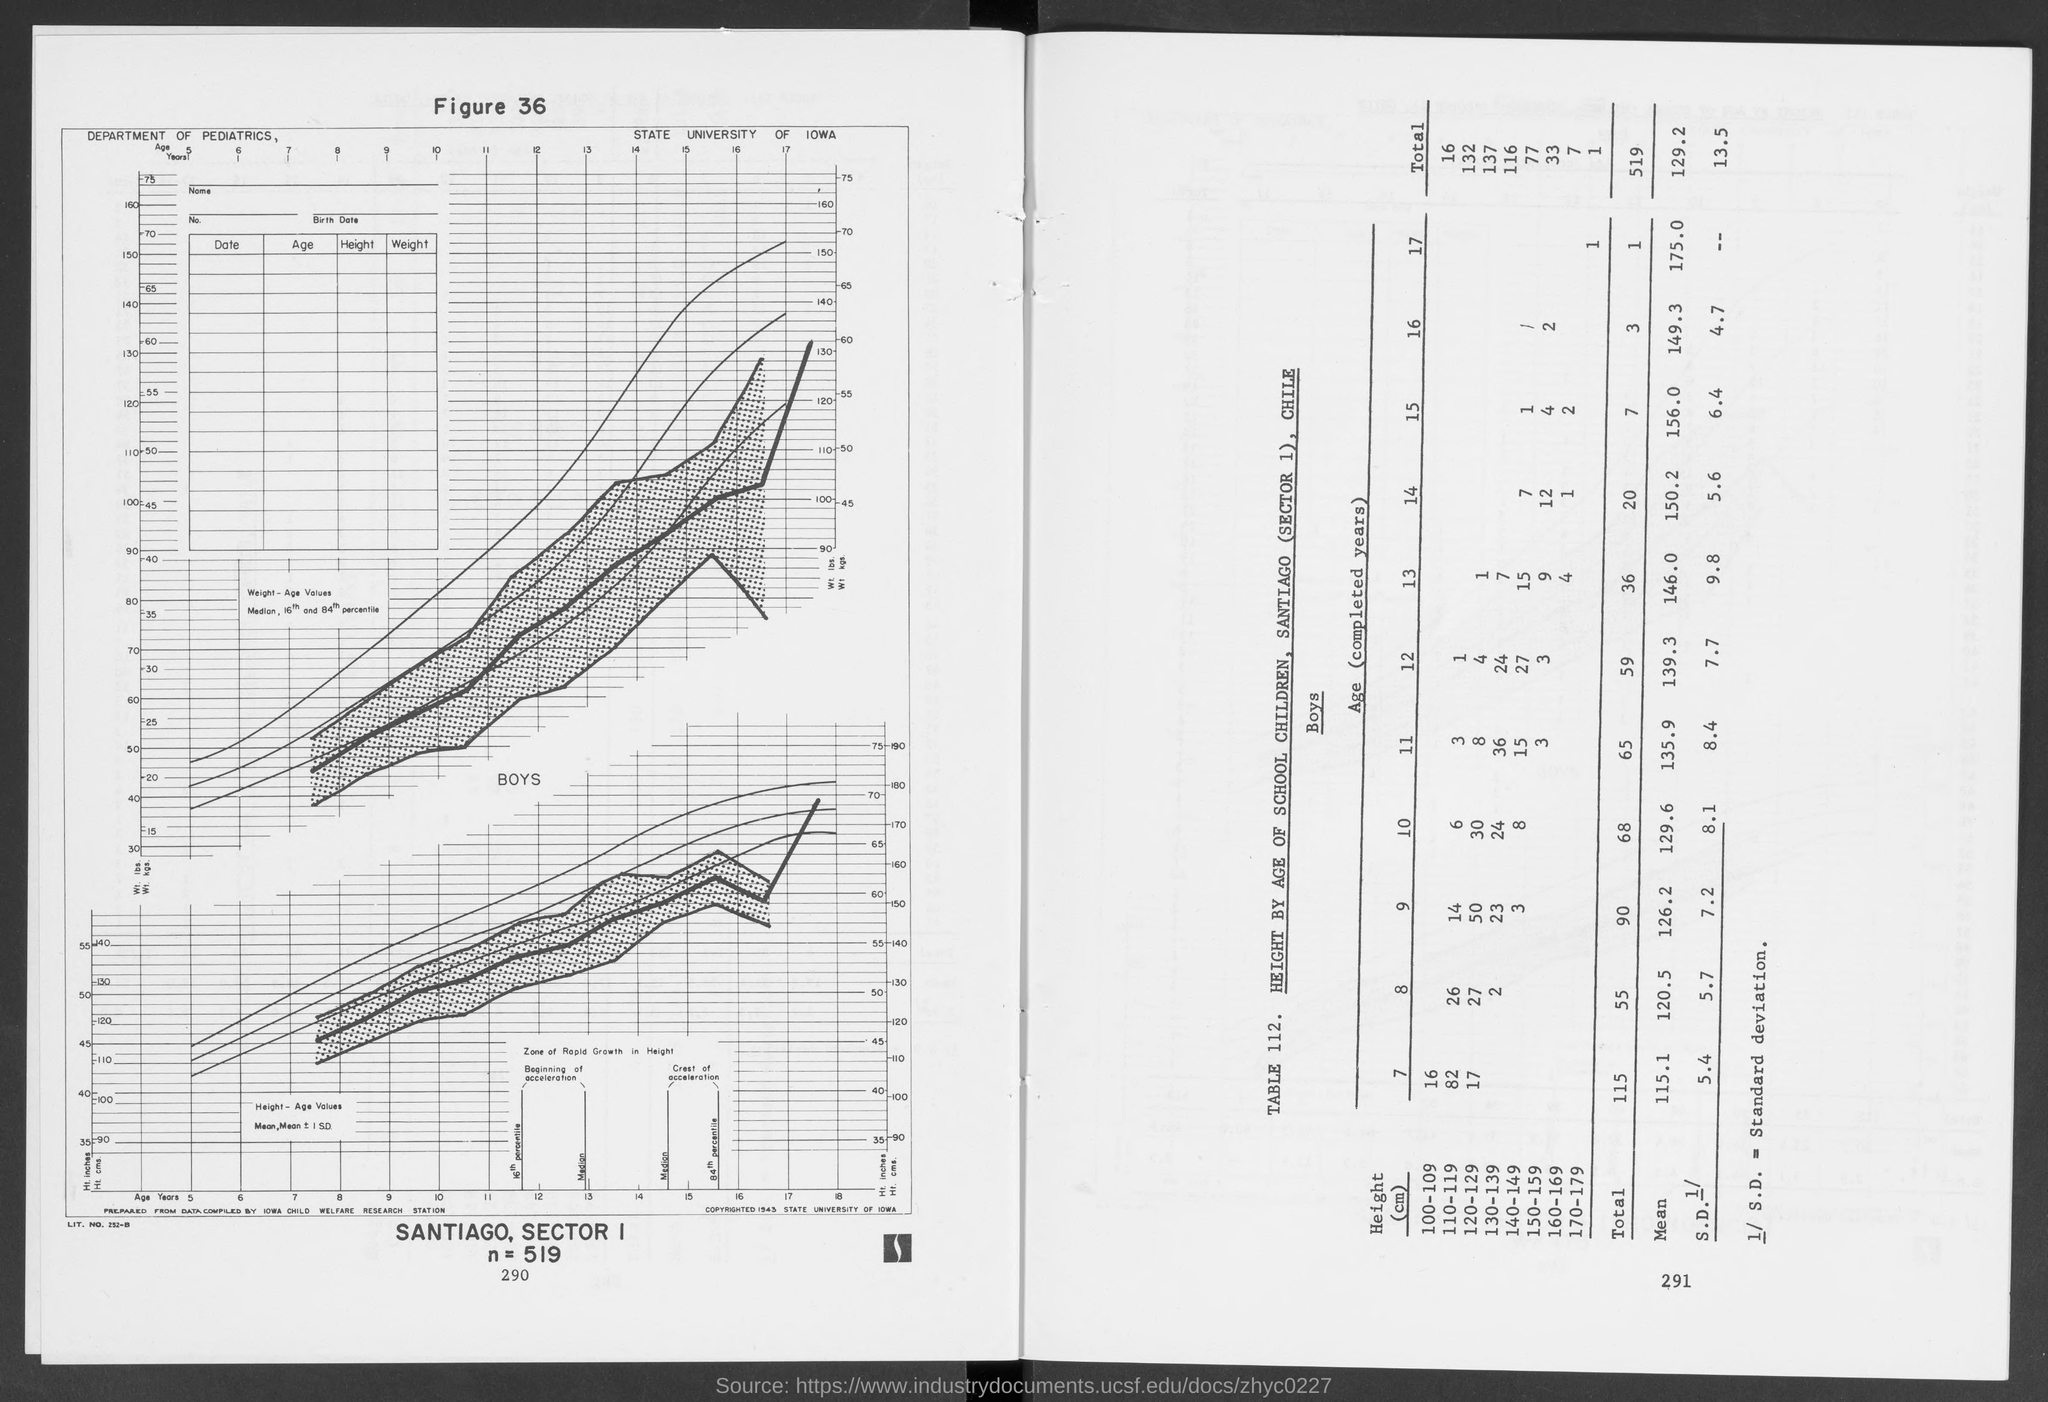What is the full form of S.D?
Provide a short and direct response. Standard deviation. What is the value of n?
Your answer should be very brief. N = 519. What is the number of children of the age of 7 having a height in the range of 100-109?
Provide a succinct answer. 16. Which range of height has the maximum number of children?
Keep it short and to the point. 120-129. Which range of height has the minimum number of children?
Offer a very short reply. 170-179. What is the number of children of the age of 12 having a height in the range of 130-139?
Give a very brief answer. 24. 